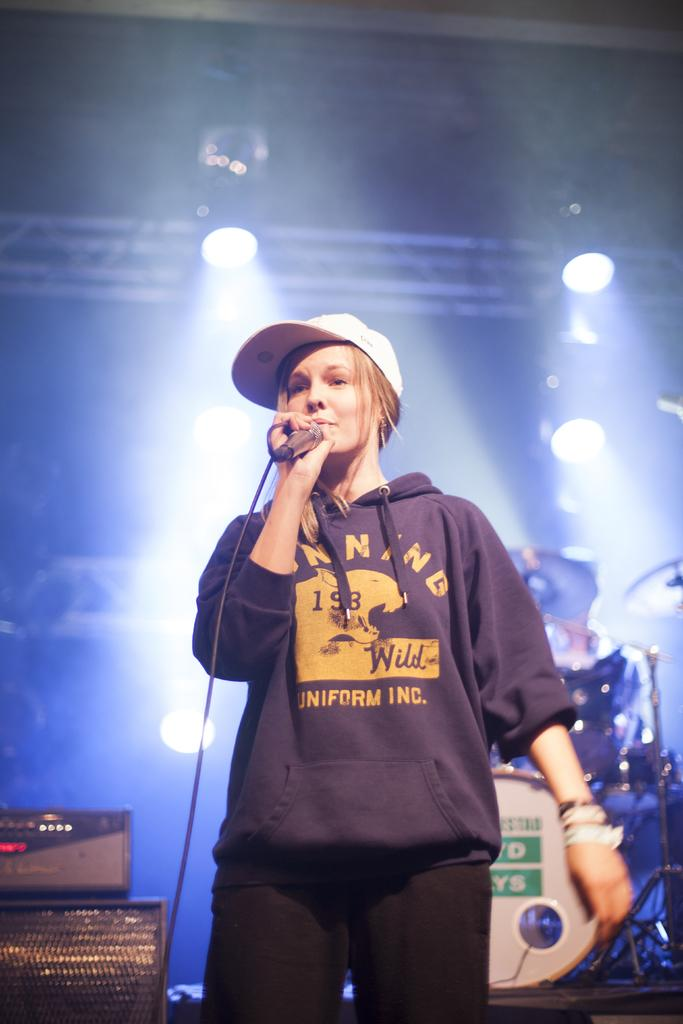Who is the main subject in the image? There is a woman in the image. What is the woman wearing on her head? The woman is wearing a cap. What is the woman holding in her hand? The woman is holding a mic in her hand. What is the woman's posture in the image? The woman is standing. What can be seen in the background of the image? There are drums, lights, and speakers in the background of the image. What type of curtain is hanging in the background of the image? There is no curtain present in the background of the image. What kind of flowers can be seen near the woman in the image? There are no flowers visible near the woman in the image. 